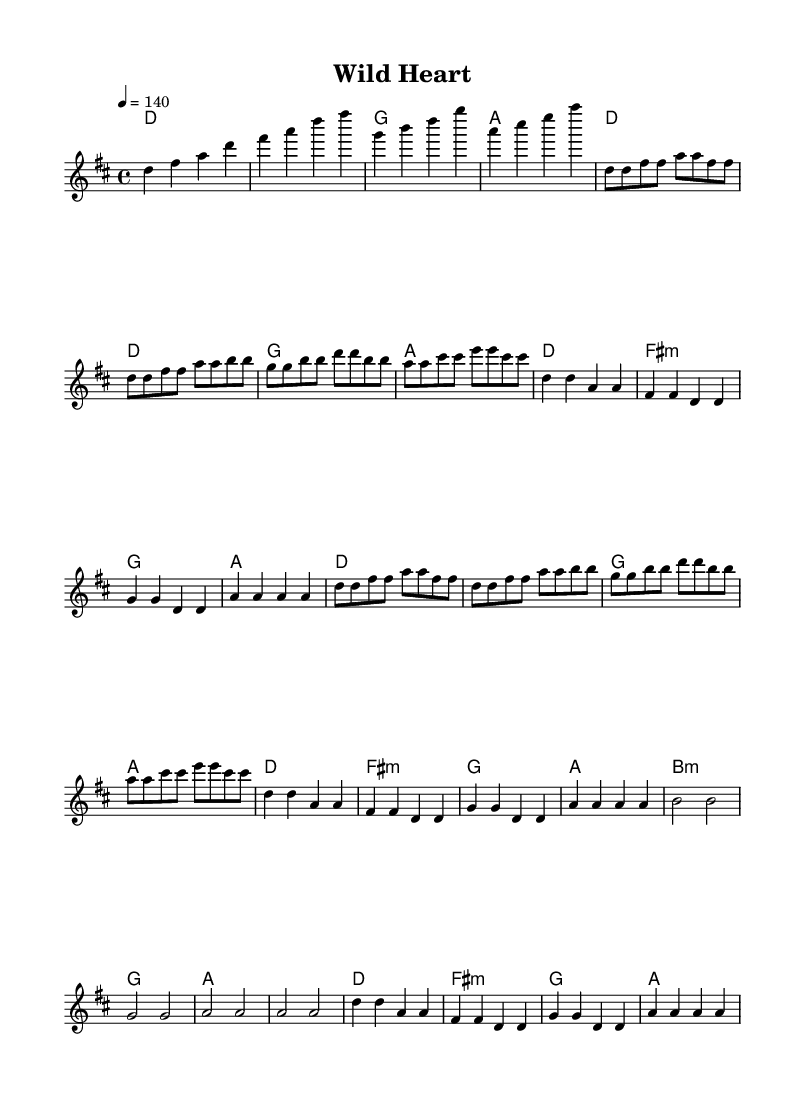What is the key signature of this music? The key signature is indicated by the presence of two sharps (F# and C#) in the music sheet, which is typical for D major.
Answer: D major What is the time signature of this music? The time signature is located at the beginning of the music and is expressed as 4/4, which means there are four beats in each measure.
Answer: 4/4 What is the tempo marking for this piece? The tempo marking indicated at the start of the music is a quarter note equals 140 beats per minute, specifying how fast the music should be played.
Answer: 140 How many sections does the song have? By analyzing the structure, there is an intro, verse, chorus, bridge, and repetitions, totaling four distinct sections that contribute to the song format.
Answer: Four What is the chord that accompanies the chorus? The chords played during the chorus section can be identified from the harmonies written above the melody line, showing D, A, F#, and G as the corresponding chords for that part.
Answer: D, A, F#, G What type of thematic element does the song celebrate? The song embodies lyrical themes centered around environmental conservation, highlighted through its energetic pop-rock anthems.
Answer: Environmental conservation What is the relative pitch range of the melody? Observing the melody's placement on the staff and the note lengths, it spans from D4 to A5, indicating a relatively wide vocal range suitable for pop-rock anthems.
Answer: D4 to A5 